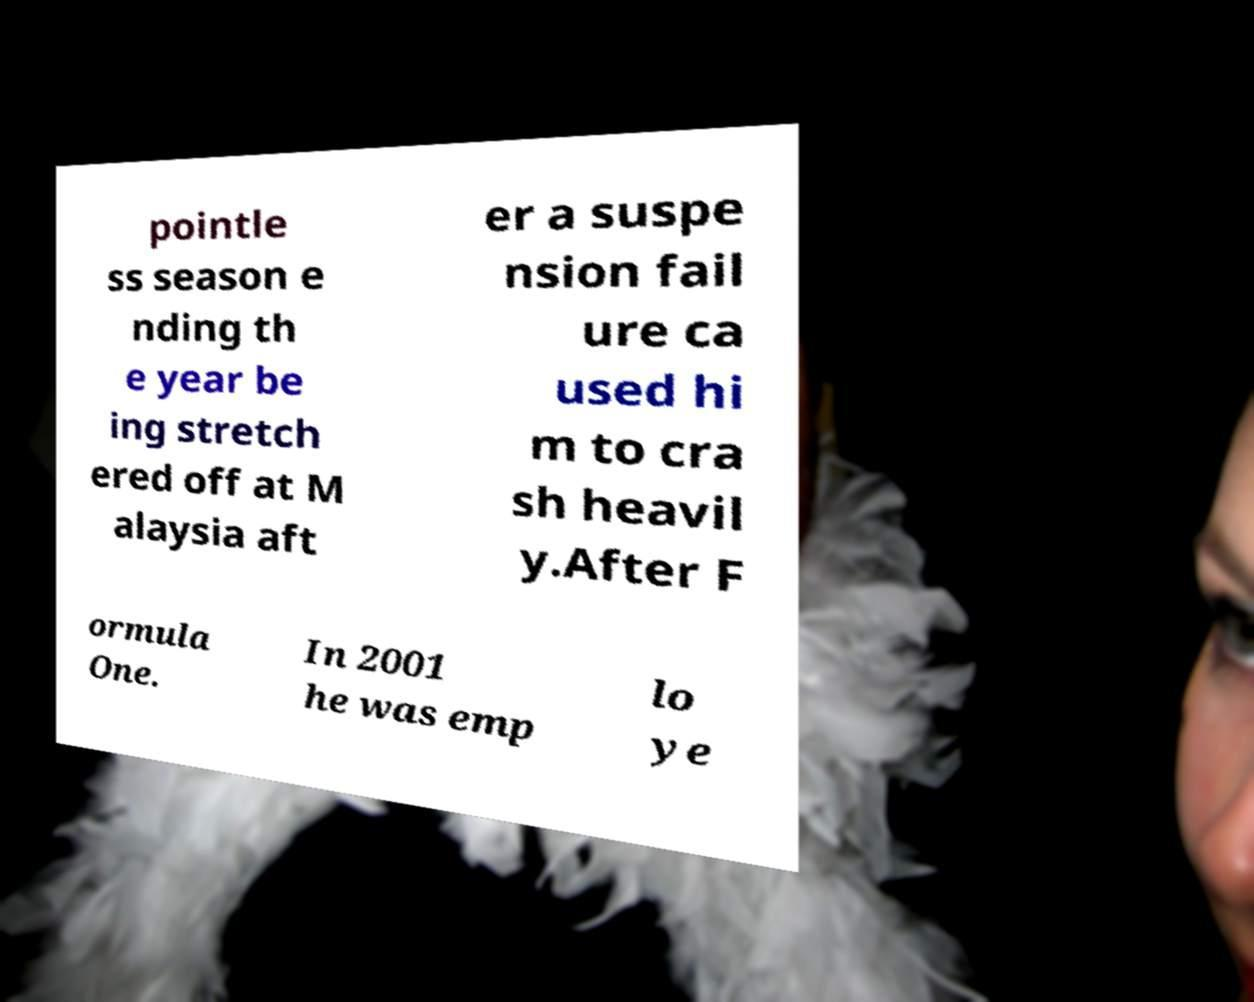Could you assist in decoding the text presented in this image and type it out clearly? pointle ss season e nding th e year be ing stretch ered off at M alaysia aft er a suspe nsion fail ure ca used hi m to cra sh heavil y.After F ormula One. In 2001 he was emp lo ye 